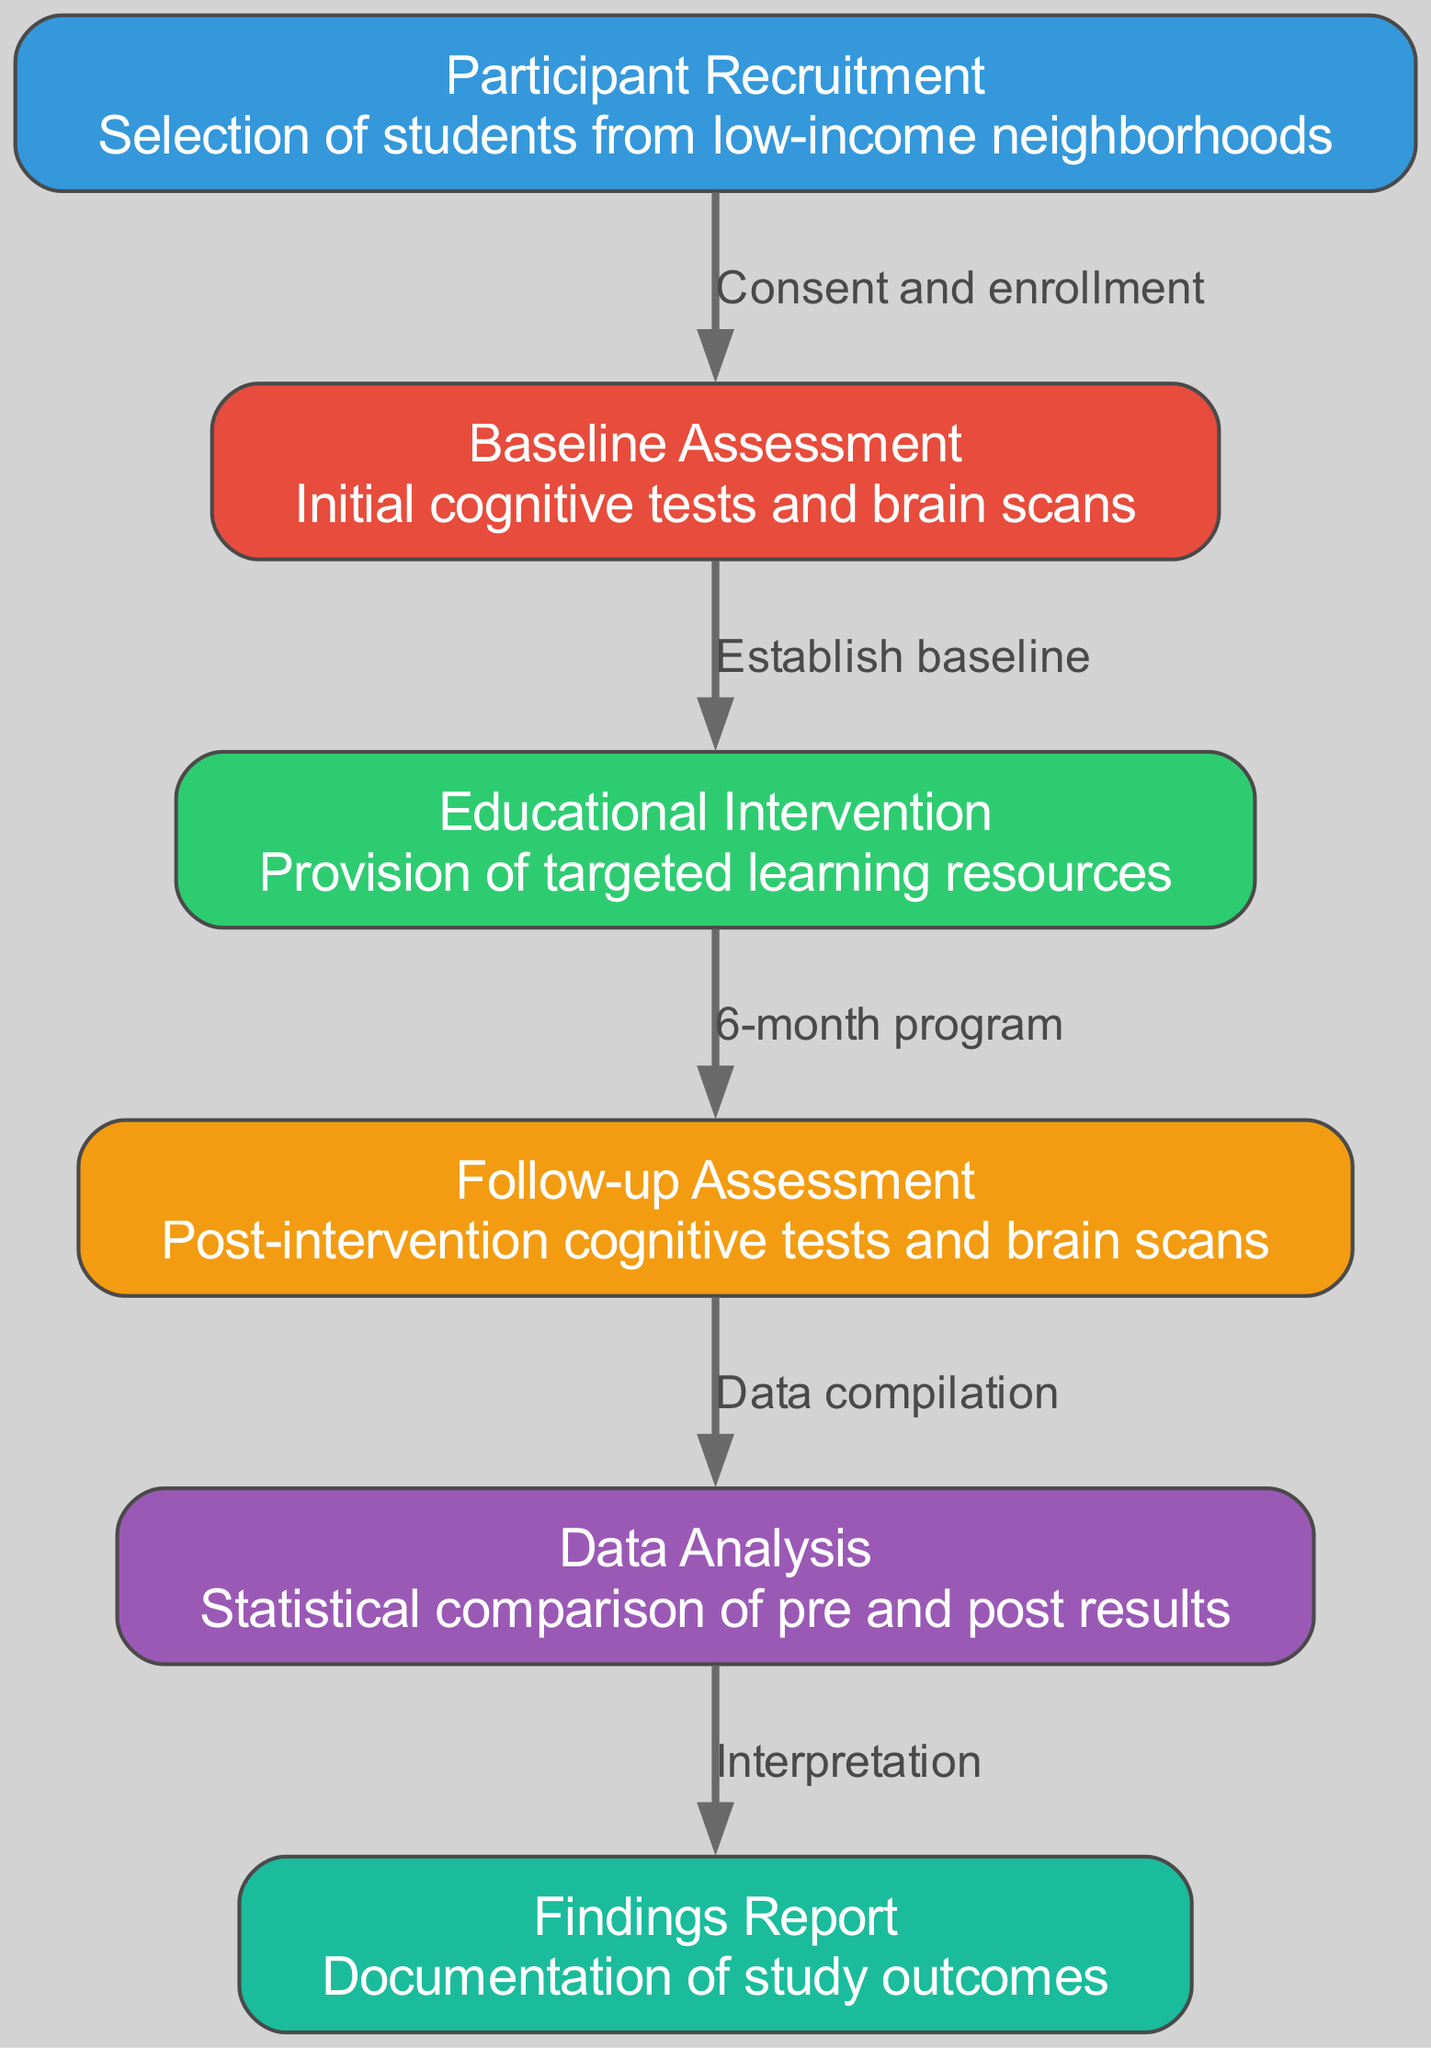What is the first step in the process? The first step shown in the diagram is "Participant Recruitment." This is the starting point where students are selected for the study.
Answer: Participant Recruitment How many nodes are in the diagram? By counting the nodes listed in the diagram, there are a total of six nodes depicted that represent different stages of the study process.
Answer: 6 What does the edge labeled "6-month program" connect? This edge connects "Educational Intervention" to "Follow-up Assessment." It indicates the duration of the intervention before the assessment occurs.
Answer: Educational Intervention and Follow-up Assessment What is the final outcome documented in the study? The last node in the diagram is "Findings Report," which represents the documentation of the study's outcomes following data analysis.
Answer: Findings Report What is the relationship between "Baseline Assessment" and "Educational Intervention"? The relationship is established by the edge labeled "Establish baseline," which indicates that the baseline assessment is completed before the educational intervention takes place.
Answer: Establish baseline Describe the purpose of the "Data Analysis" node. The "Data Analysis" node is focused on comparing the pre and post-results statistically. This is a crucial part of understanding the impact of the educational intervention on cognitive development.
Answer: Statistical comparison of pre and post results 